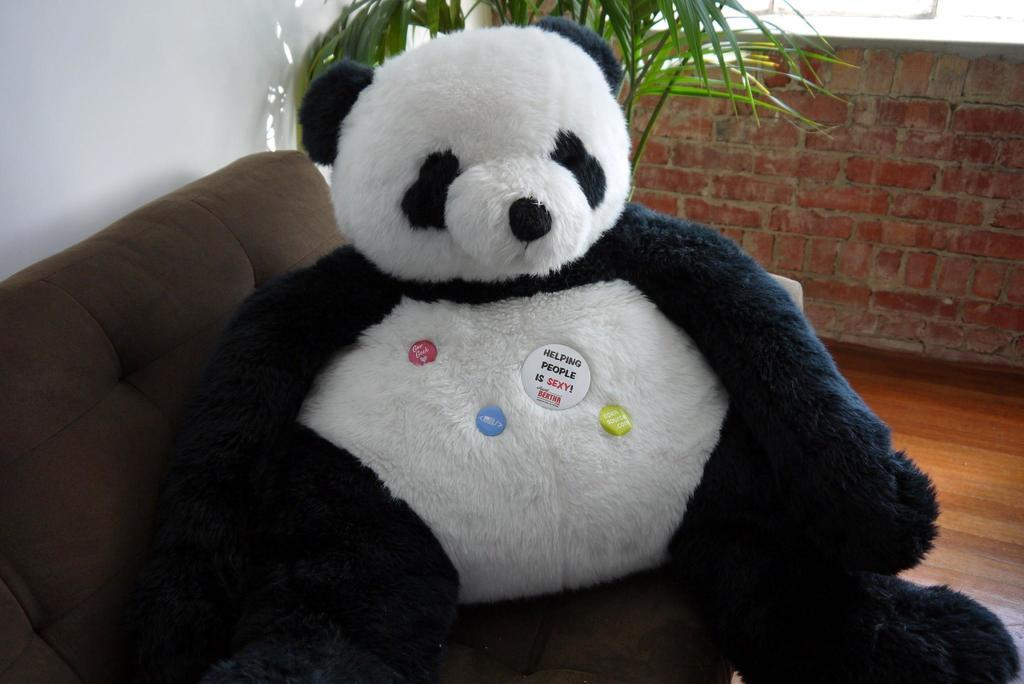What object is on the sofa in the image? There is a teddy bear on the sofa in the image. Where is the sofa located in the image? The sofa is at the bottom of the image. What can be seen in the background of the image? There is a plant and a wall in the background of the image. What type of work is the teddy bear doing on the sofa? The teddy bear is not performing any work in the image, as it is an inanimate object. 